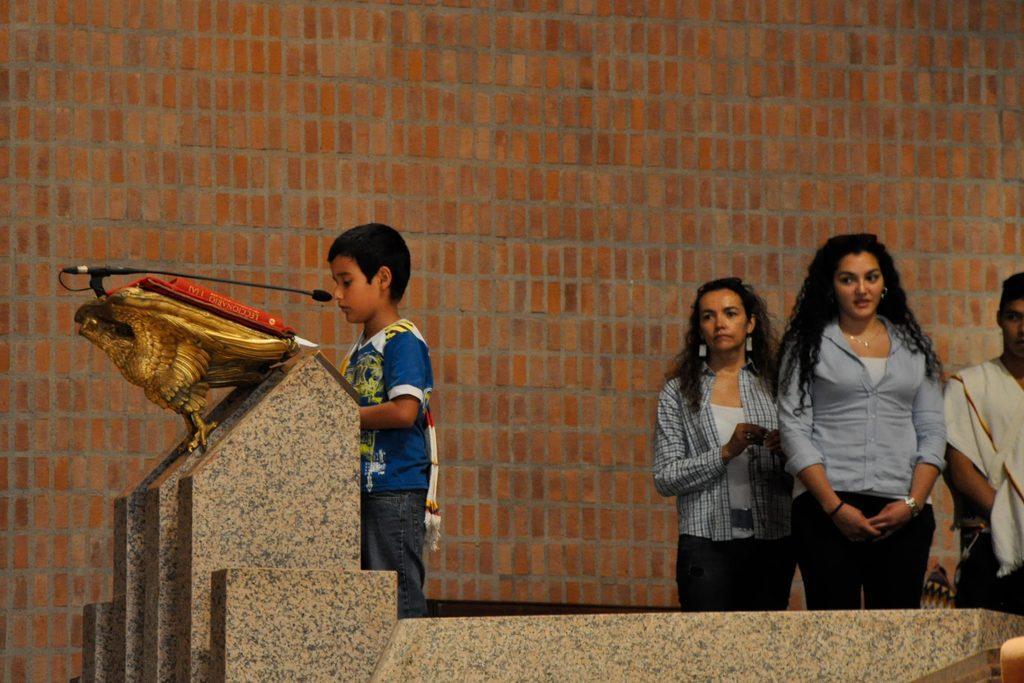Can you describe this image briefly? In this image I can see the group of people with different color dresses. I can see there is a mic in-front of one person. In the background I can see the brown color brick wall. 